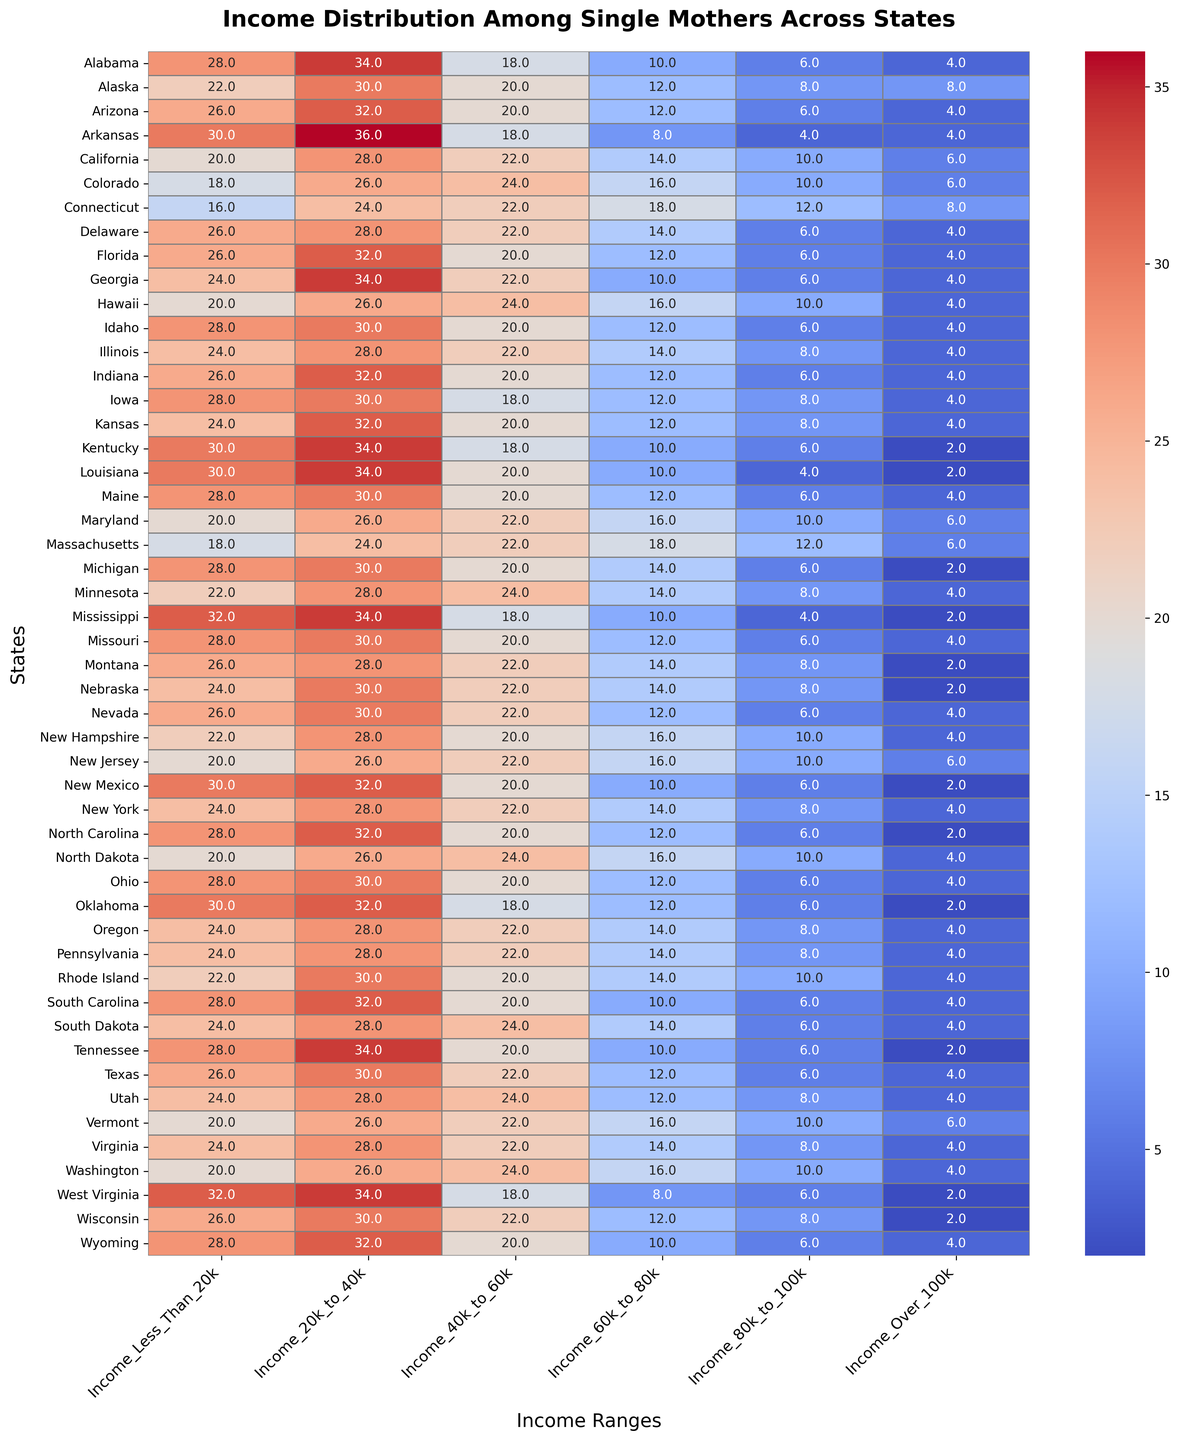Which state has the highest percentage of single mothers with an income less than $20k? Look at the first column (Income_Less_Than_20k) and identify the state with the highest value. Mississippi has the highest value at 32%.
Answer: Mississippi Which states have the highest and lowest percentages of single mothers with income between $80k and $100k? Look at the column labeled Income_80k_to_100k, then identify the states with the highest and lowest values. Connecticut and New Hampshire have the highest percentage at 12%, while Kentucky, Louisiana, Mississippi, Montana, and Nebraska have the lowest percentage at 2%.
Answer: Connecticut and New Hampshire; Kentucky, Louisiana, Mississippi, Montana, and Nebraska Is the percentage of single mothers earning over $100k generally higher in northeastern states compared to southern states? Observe the values in the Income_Over_100k column and compare northeastern states (like Connecticut, New Jersey, and Massachusetts) and southern states (like Alabama, Arkansas, Georgia, and Louisiana). Northeastern states generally have higher values (ranging from 6% to 8%) compared to southern states (ranging from 2% to 4%).
Answer: Yes What's the average percentage of single mothers with an income between $60k and $80k across all the states? Sum the values in the Income_60k_to_80k column and divide by the number of states (51). The sum is 676 and the average is 676/51 ≈ 13.3%.
Answer: 13.3% Are there any states where the percentage of single mothers earning between $40k and $60k exceeds 30%? Refer to the Income_40k_to_60k column and check if any values exceed 30%. No state has a value exceeding 30%.
Answer: No Which state has a more uniform distribution of income levels among single mothers? Look at the heatmap and find the state where percentages across different income ranges are closest to each other. Maryland and Hawaii appear to have relatively uniform distributions with smaller variations across income ranges.
Answer: Maryland and Hawaii Compare the income distribution of single mothers in California and Texas. Which state has higher percentages in the higher income brackets ($80k and above)? Examine the columns labeled Income_80k_to_100k and Income_Over_100k for both states. California has 10% in $80k-$100k and 6% in Over $100k, while Texas has 6% in $80k-$100k and 4% in Over $100k.
Answer: California Which state has the lowest percentage of single mothers earning less than $20k? Look at the first column (Income_Less_Than_20k) and identify the lowest value. Connecticut and Massachusetts have the lowest value of 16%.
Answer: Connecticut and Massachusetts 